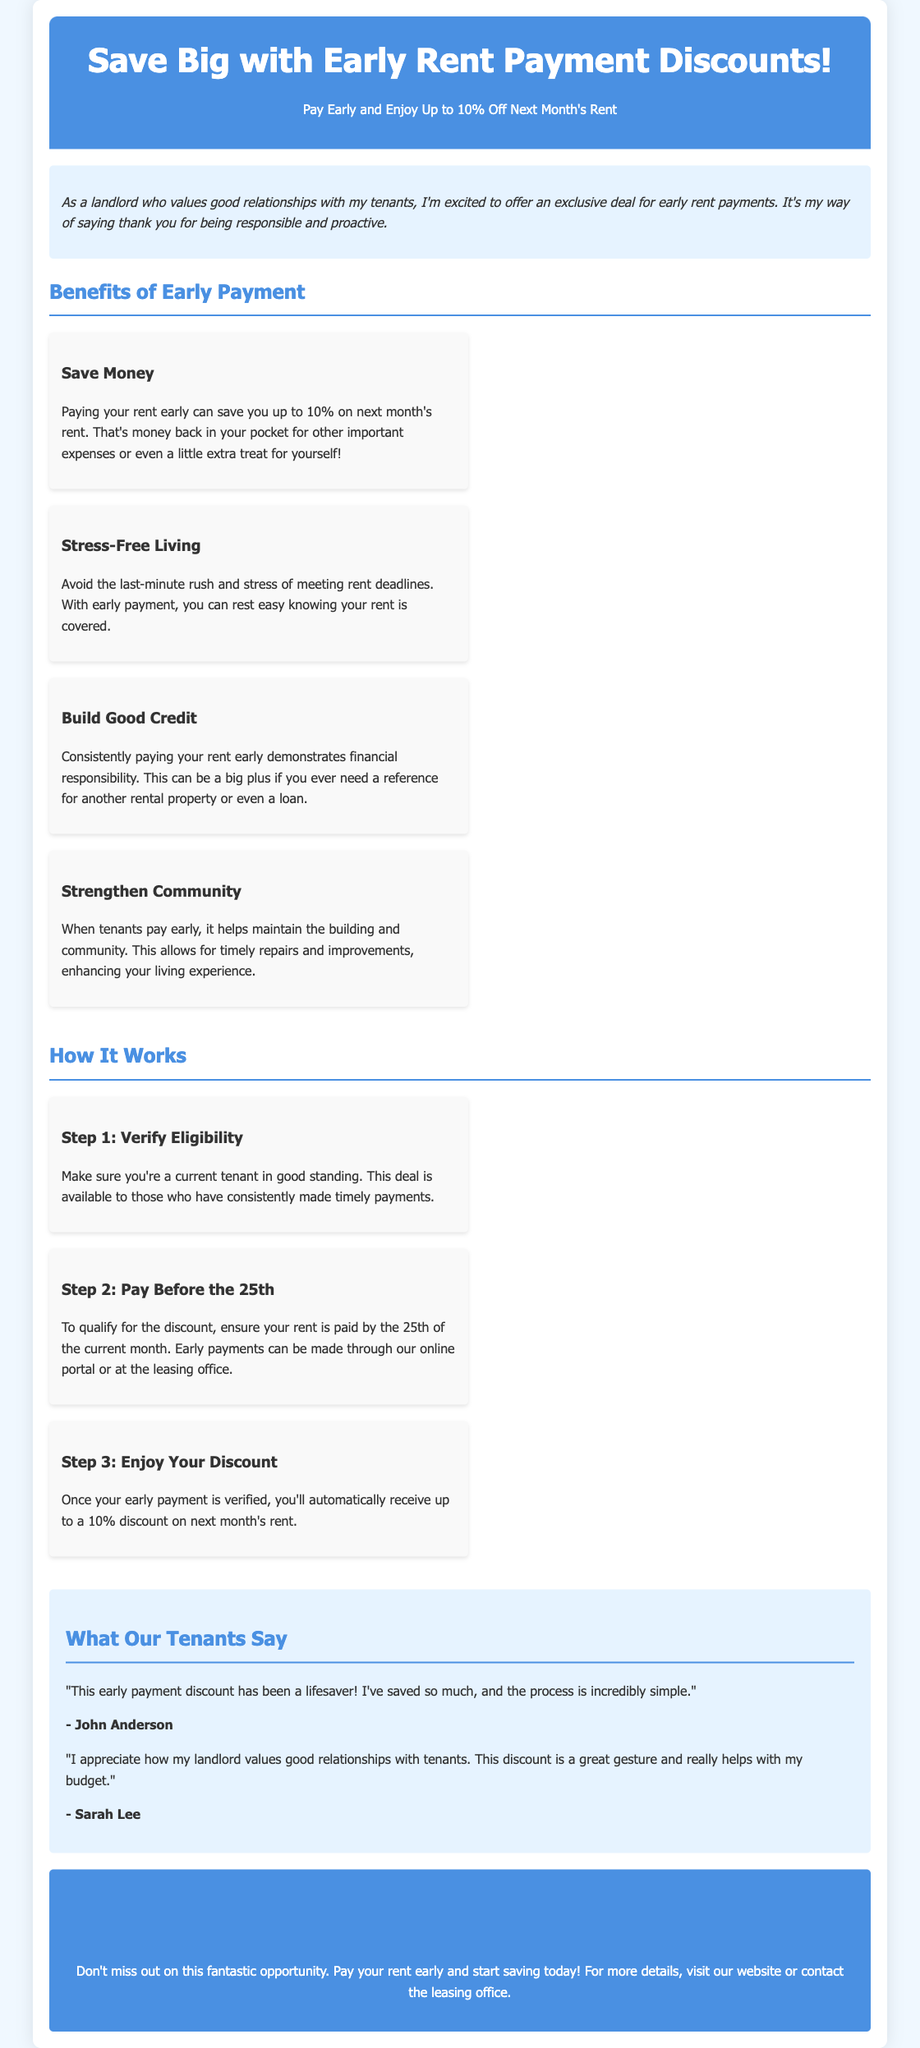What is the maximum discount percentage for early rent payments? The document states that tenants can save up to 10% on next month's rent when they pay early.
Answer: 10% By when do tenants need to pay to qualify for the discount? According to the document, to qualify for the discount, tenants need to pay their rent by the 25th of the current month.
Answer: 25th What benefit does early payment provide regarding stress? One of the benefits mentioned is that early payment helps avoid the last-minute rush and stress of meeting rent deadlines.
Answer: Stress-Free Living Who is eligible for the early payment discount? The document specifies that current tenants in good standing are eligible for the early payment discount.
Answer: Current tenants What is a benefit of paying rent early regarding community maintenance? The document mentions that early payments help maintain the building and community, allowing for timely repairs and improvements.
Answer: Strengthen Community What is the first step a tenant must take to benefit from the discount? Tenants must verify their eligibility as the first step to benefit from the discount.
Answer: Verify Eligibility What do tenants generally say about the early payment discount? The testimonials in the document show that tenants appreciate the discount and find it helpful for their budgets.
Answer: Lifesaver What is the title of the document? The title of the document is "Early Rent Payment Discounts."
Answer: Early Rent Payment Discounts 